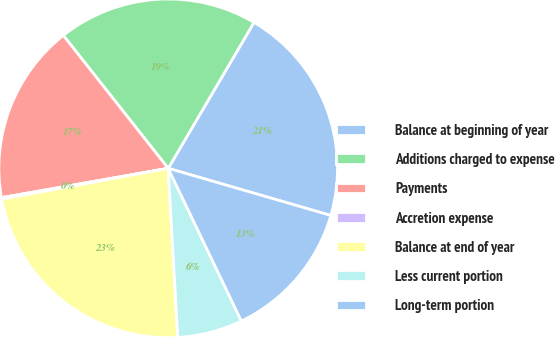Convert chart. <chart><loc_0><loc_0><loc_500><loc_500><pie_chart><fcel>Balance at beginning of year<fcel>Additions charged to expense<fcel>Payments<fcel>Accretion expense<fcel>Balance at end of year<fcel>Less current portion<fcel>Long-term portion<nl><fcel>21.03%<fcel>19.09%<fcel>17.14%<fcel>0.15%<fcel>22.98%<fcel>6.21%<fcel>13.4%<nl></chart> 